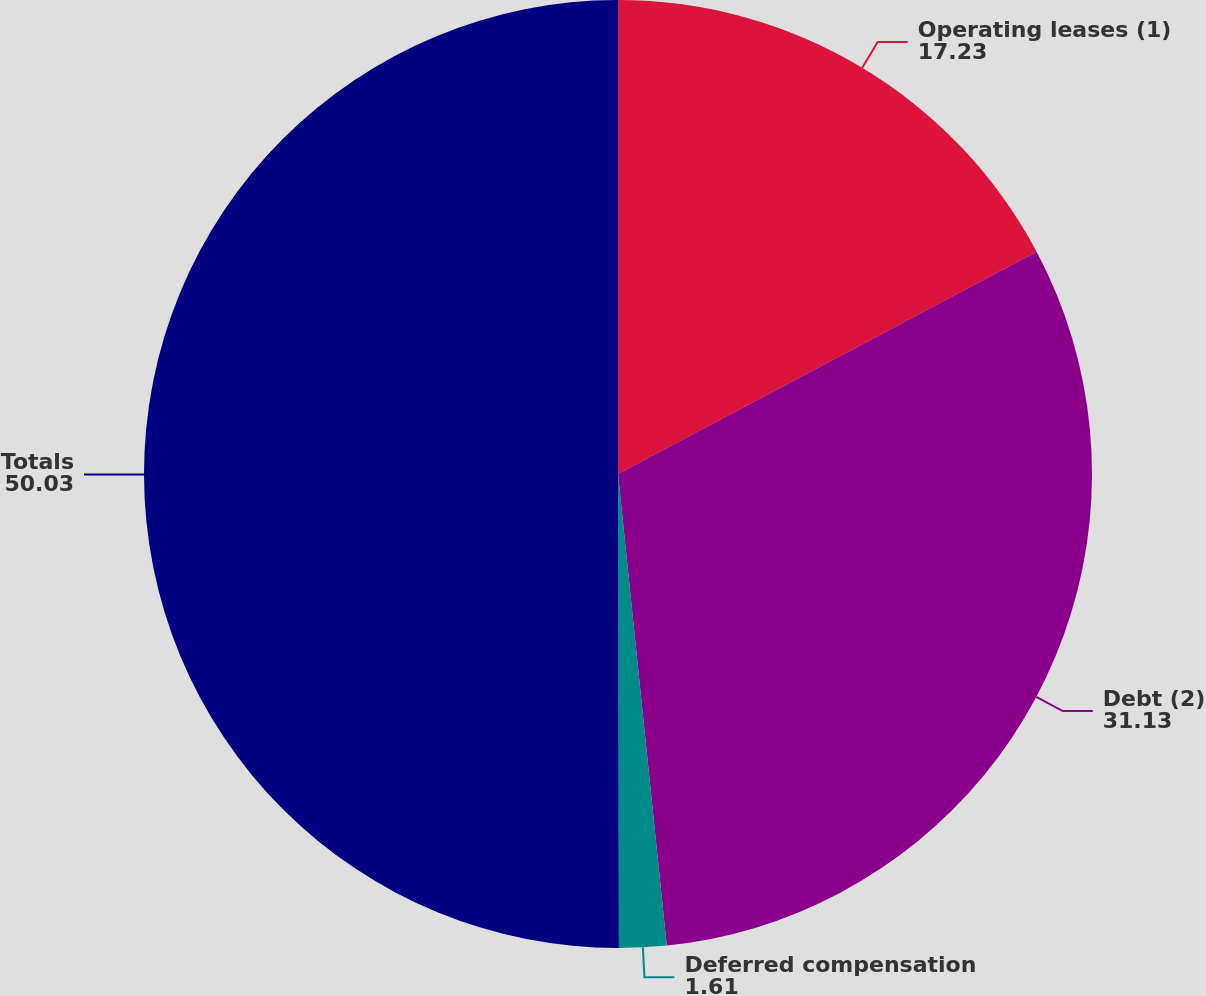<chart> <loc_0><loc_0><loc_500><loc_500><pie_chart><fcel>Operating leases (1)<fcel>Debt (2)<fcel>Deferred compensation<fcel>Totals<nl><fcel>17.23%<fcel>31.13%<fcel>1.61%<fcel>50.03%<nl></chart> 